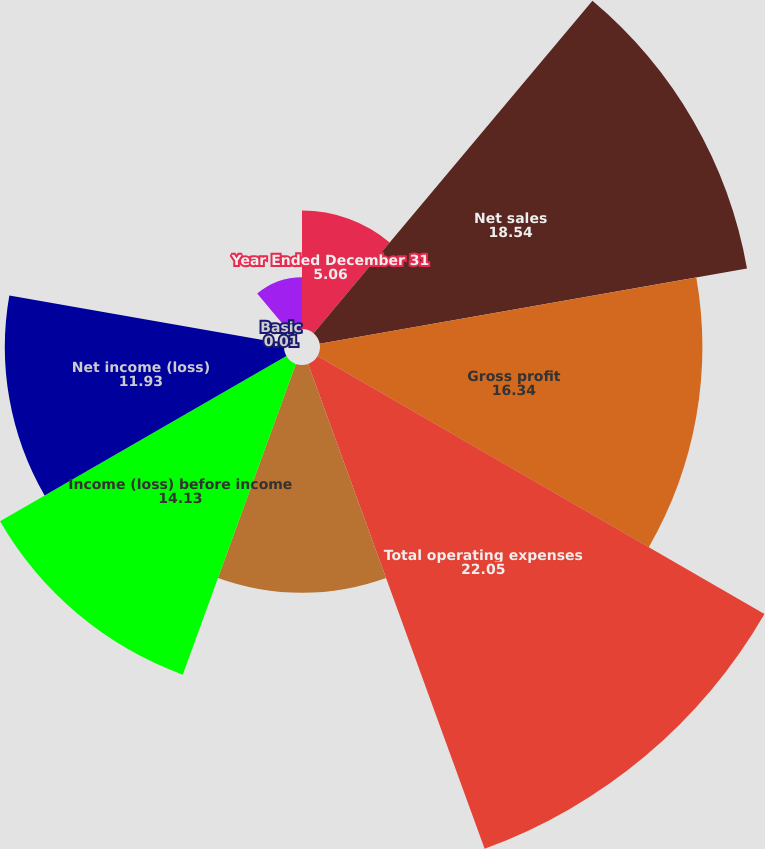Convert chart. <chart><loc_0><loc_0><loc_500><loc_500><pie_chart><fcel>Year Ended December 31<fcel>Net sales<fcel>Gross profit<fcel>Total operating expenses<fcel>Operating income (loss)<fcel>Income (loss) before income<fcel>Net income (loss)<fcel>Basic<fcel>Assuming dilution<nl><fcel>5.06%<fcel>18.54%<fcel>16.34%<fcel>22.05%<fcel>9.73%<fcel>14.13%<fcel>11.93%<fcel>0.01%<fcel>2.21%<nl></chart> 